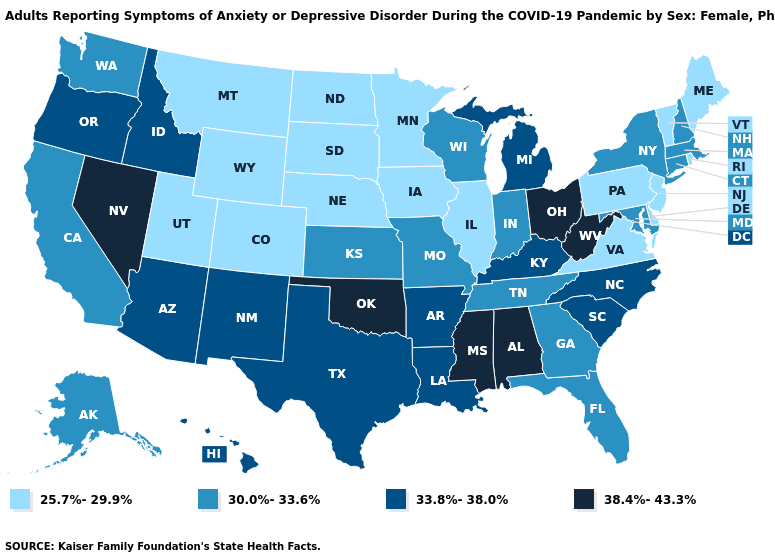Name the states that have a value in the range 30.0%-33.6%?
Quick response, please. Alaska, California, Connecticut, Florida, Georgia, Indiana, Kansas, Maryland, Massachusetts, Missouri, New Hampshire, New York, Tennessee, Washington, Wisconsin. What is the value of Tennessee?
Quick response, please. 30.0%-33.6%. Name the states that have a value in the range 25.7%-29.9%?
Give a very brief answer. Colorado, Delaware, Illinois, Iowa, Maine, Minnesota, Montana, Nebraska, New Jersey, North Dakota, Pennsylvania, Rhode Island, South Dakota, Utah, Vermont, Virginia, Wyoming. What is the value of Oregon?
Short answer required. 33.8%-38.0%. What is the lowest value in states that border California?
Give a very brief answer. 33.8%-38.0%. Is the legend a continuous bar?
Write a very short answer. No. What is the value of Vermont?
Keep it brief. 25.7%-29.9%. Name the states that have a value in the range 33.8%-38.0%?
Keep it brief. Arizona, Arkansas, Hawaii, Idaho, Kentucky, Louisiana, Michigan, New Mexico, North Carolina, Oregon, South Carolina, Texas. What is the lowest value in states that border New Hampshire?
Answer briefly. 25.7%-29.9%. Name the states that have a value in the range 30.0%-33.6%?
Be succinct. Alaska, California, Connecticut, Florida, Georgia, Indiana, Kansas, Maryland, Massachusetts, Missouri, New Hampshire, New York, Tennessee, Washington, Wisconsin. Among the states that border Kansas , which have the highest value?
Keep it brief. Oklahoma. Name the states that have a value in the range 33.8%-38.0%?
Be succinct. Arizona, Arkansas, Hawaii, Idaho, Kentucky, Louisiana, Michigan, New Mexico, North Carolina, Oregon, South Carolina, Texas. How many symbols are there in the legend?
Answer briefly. 4. What is the lowest value in the USA?
Be succinct. 25.7%-29.9%. Does Alabama have the highest value in the USA?
Give a very brief answer. Yes. 